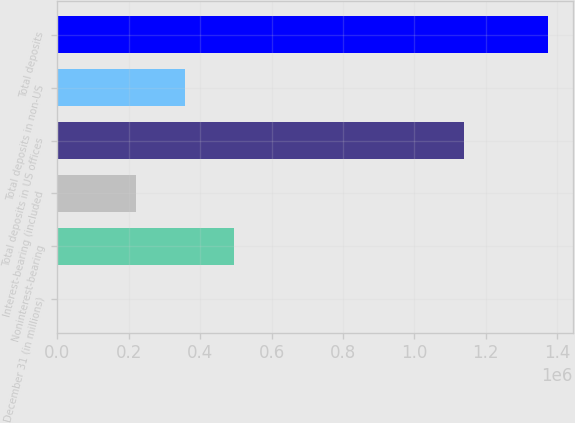<chart> <loc_0><loc_0><loc_500><loc_500><bar_chart><fcel>December 31 (in millions)<fcel>Noninterest-bearing<fcel>Interest-bearing (included<fcel>Total deposits in US offices<fcel>Total deposits in non-US<fcel>Total deposits<nl><fcel>2016<fcel>496268<fcel>221635<fcel>1.13878e+06<fcel>358951<fcel>1.37518e+06<nl></chart> 